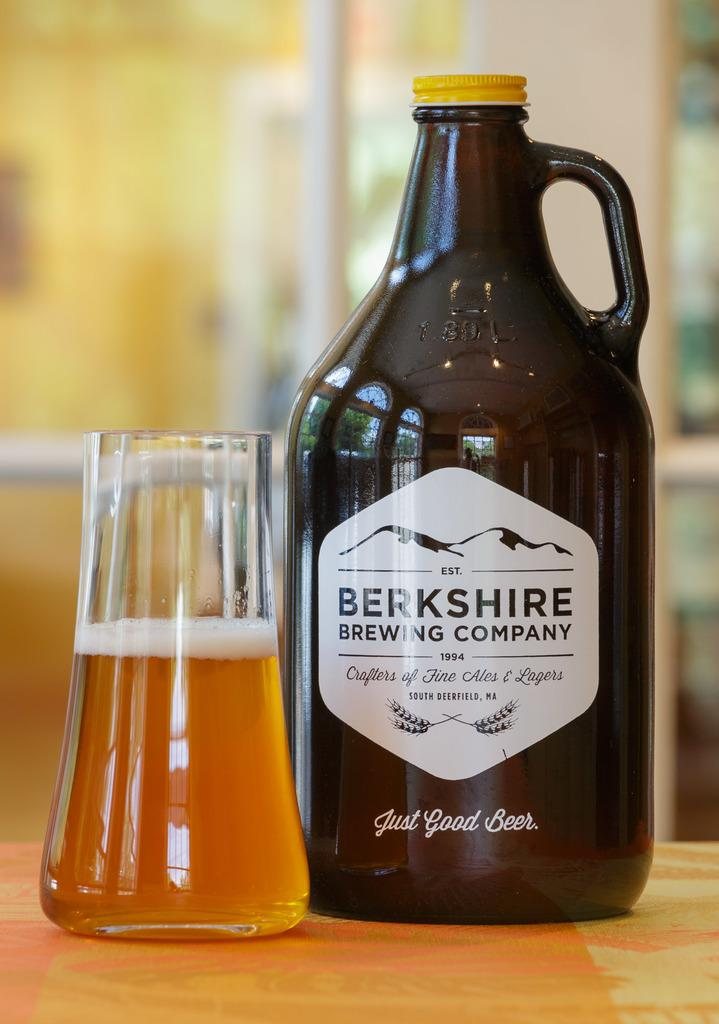<image>
Write a terse but informative summary of the picture. A bottle with a Berkshire Brewing Company is on a table next to a glass. 